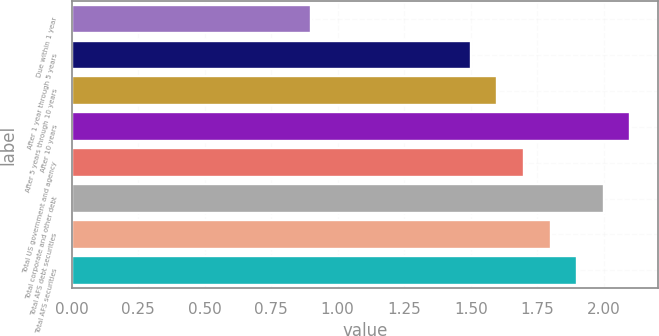Convert chart to OTSL. <chart><loc_0><loc_0><loc_500><loc_500><bar_chart><fcel>Due within 1 year<fcel>After 1 year through 5 years<fcel>After 5 years through 10 years<fcel>After 10 years<fcel>Total US government and agency<fcel>Total corporate and other debt<fcel>Total AFS debt securities<fcel>Total AFS securities<nl><fcel>0.9<fcel>1.5<fcel>1.6<fcel>2.1<fcel>1.7<fcel>2<fcel>1.8<fcel>1.9<nl></chart> 